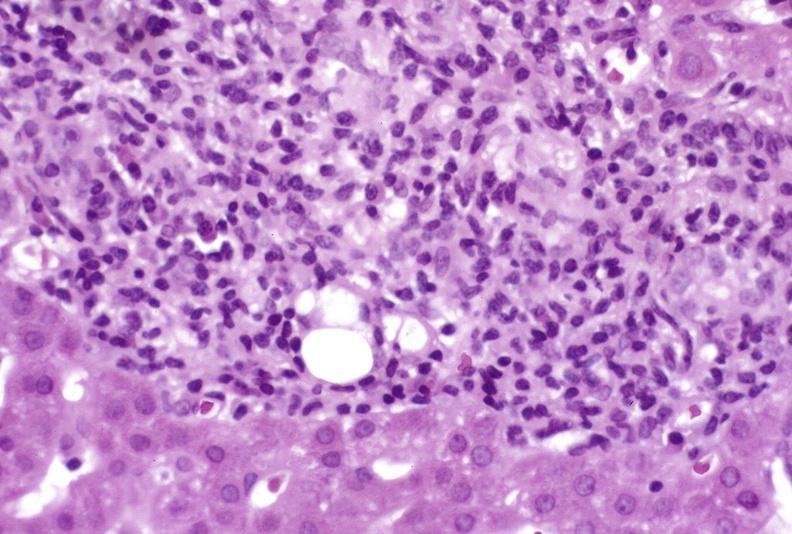does this image show mild-to-moderate acute rejection?
Answer the question using a single word or phrase. Yes 